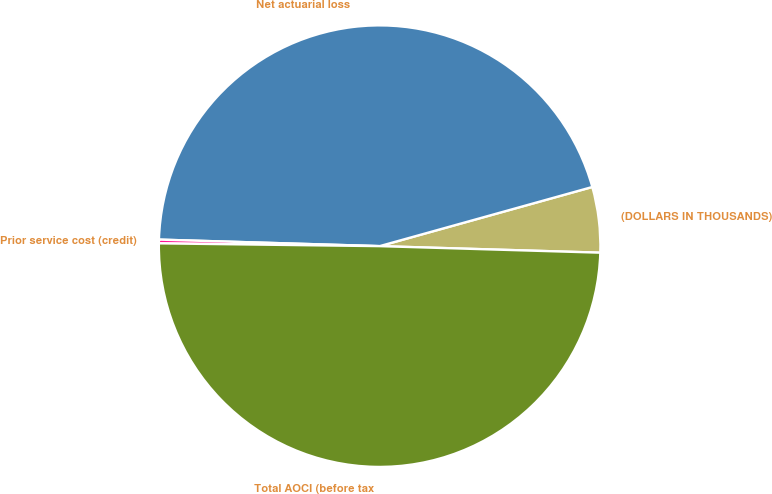<chart> <loc_0><loc_0><loc_500><loc_500><pie_chart><fcel>(DOLLARS IN THOUSANDS)<fcel>Net actuarial loss<fcel>Prior service cost (credit)<fcel>Total AOCI (before tax<nl><fcel>4.79%<fcel>45.21%<fcel>0.27%<fcel>49.73%<nl></chart> 